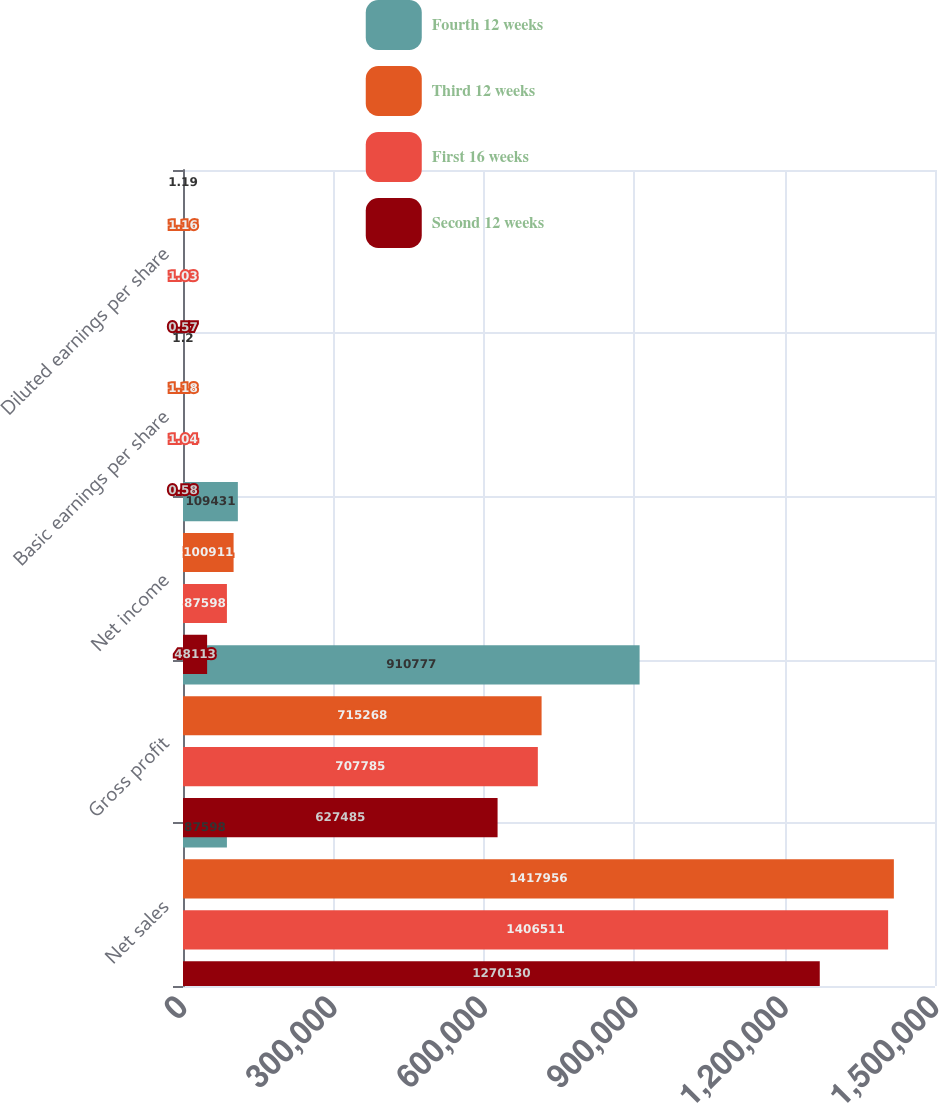Convert chart to OTSL. <chart><loc_0><loc_0><loc_500><loc_500><stacked_bar_chart><ecel><fcel>Net sales<fcel>Gross profit<fcel>Net income<fcel>Basic earnings per share<fcel>Diluted earnings per share<nl><fcel>Fourth 12 weeks<fcel>87598<fcel>910777<fcel>109431<fcel>1.2<fcel>1.19<nl><fcel>Third 12 weeks<fcel>1.41796e+06<fcel>715268<fcel>100911<fcel>1.18<fcel>1.16<nl><fcel>First 16 weeks<fcel>1.40651e+06<fcel>707785<fcel>87598<fcel>1.04<fcel>1.03<nl><fcel>Second 12 weeks<fcel>1.27013e+06<fcel>627485<fcel>48113<fcel>0.58<fcel>0.57<nl></chart> 